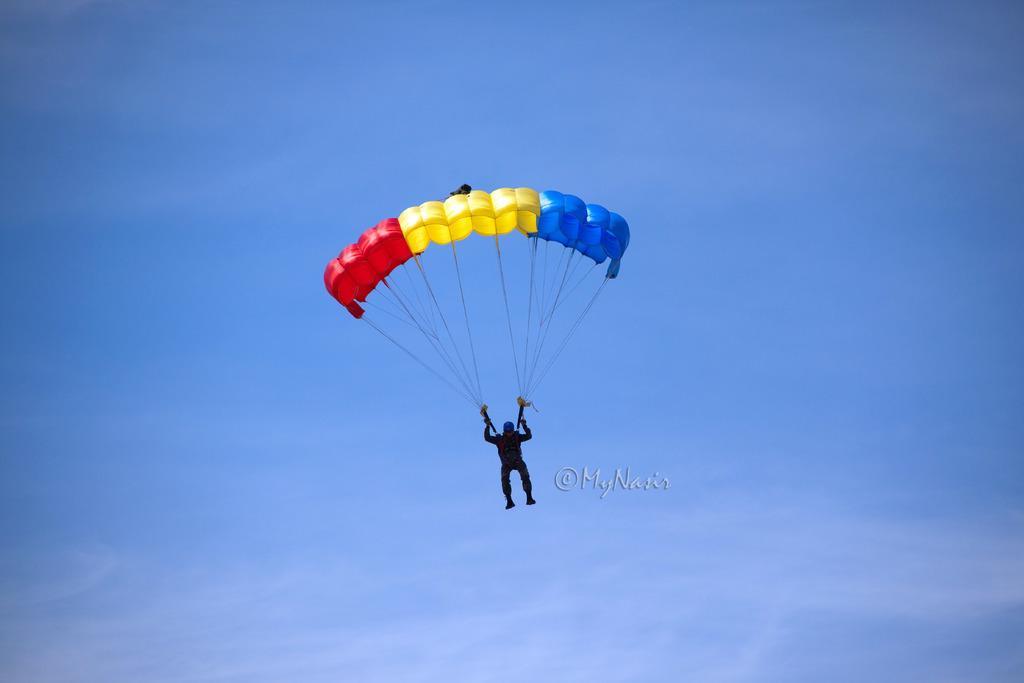How would you summarize this image in a sentence or two? In the image there is a person flying in the air with parachute and above its sky with clouds. 